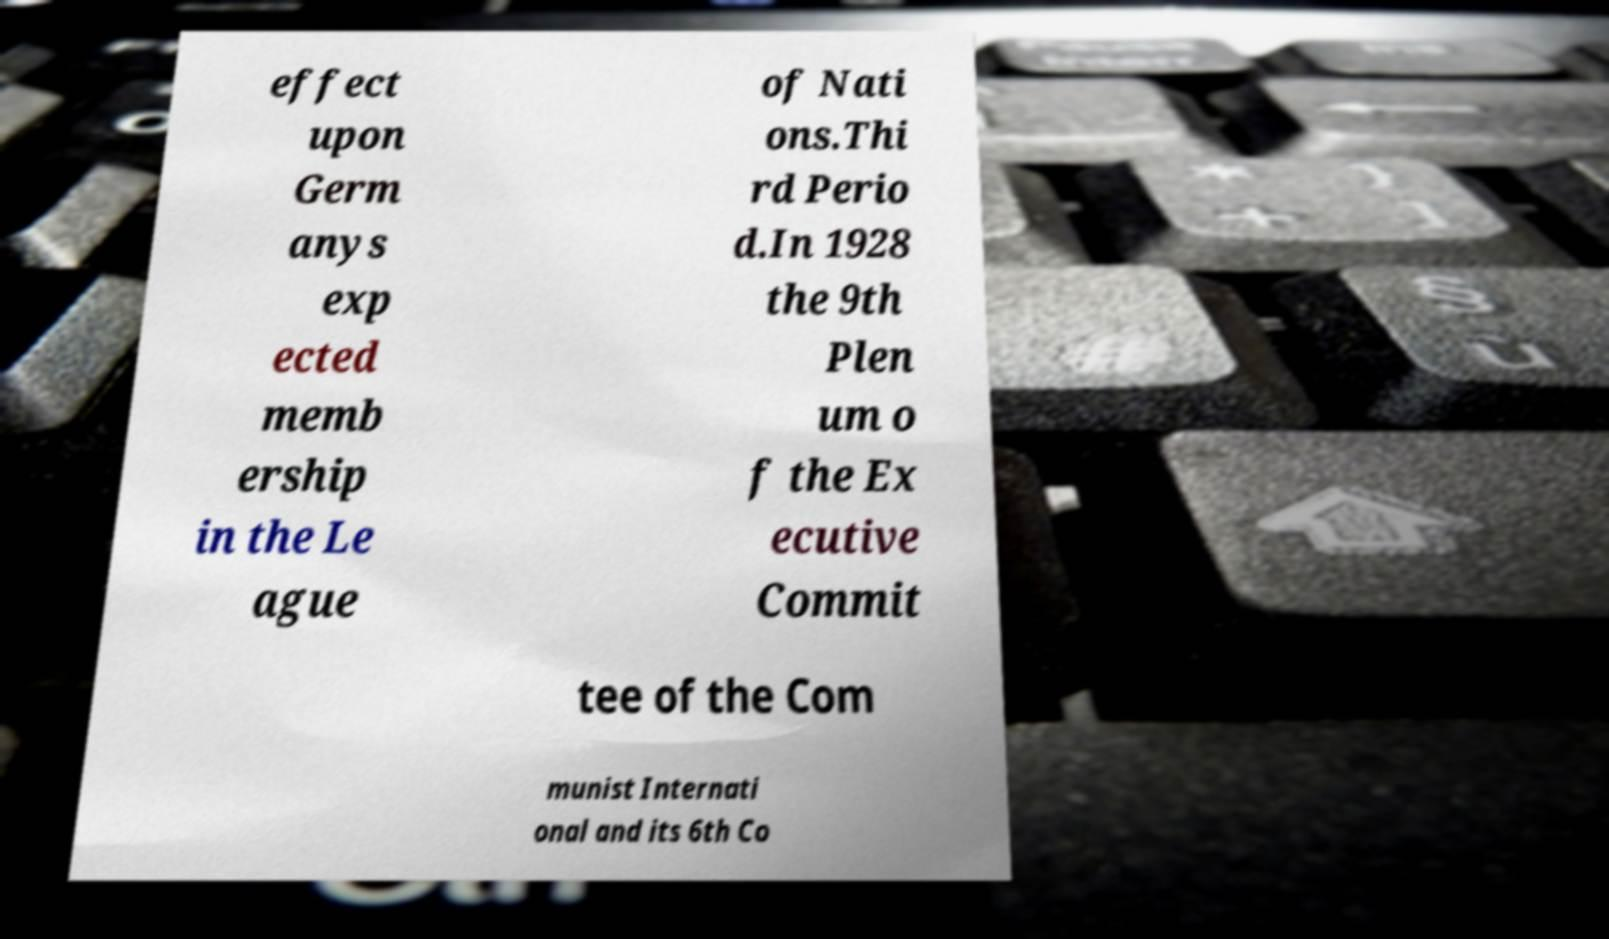Can you accurately transcribe the text from the provided image for me? effect upon Germ anys exp ected memb ership in the Le ague of Nati ons.Thi rd Perio d.In 1928 the 9th Plen um o f the Ex ecutive Commit tee of the Com munist Internati onal and its 6th Co 